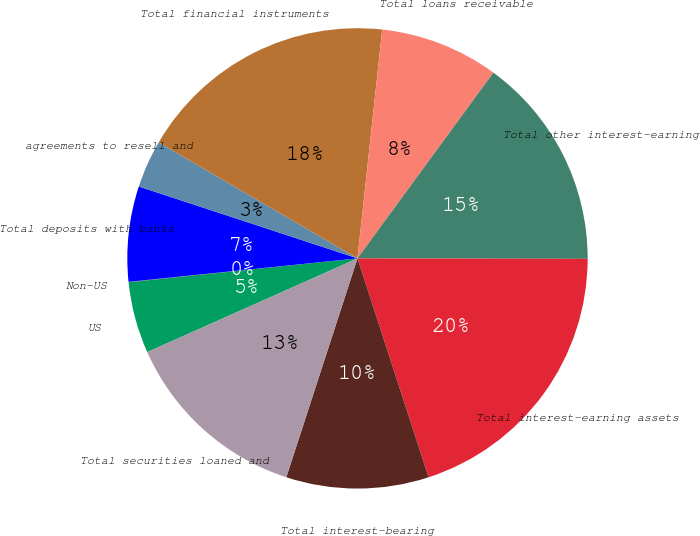<chart> <loc_0><loc_0><loc_500><loc_500><pie_chart><fcel>US<fcel>Non-US<fcel>Total deposits with banks<fcel>agreements to resell and<fcel>Total financial instruments<fcel>Total loans receivable<fcel>Total other interest-earning<fcel>Total interest-earning assets<fcel>Total interest-bearing<fcel>Total securities loaned and<nl><fcel>5.02%<fcel>0.03%<fcel>6.68%<fcel>3.35%<fcel>18.31%<fcel>8.34%<fcel>14.98%<fcel>19.97%<fcel>10.0%<fcel>13.32%<nl></chart> 